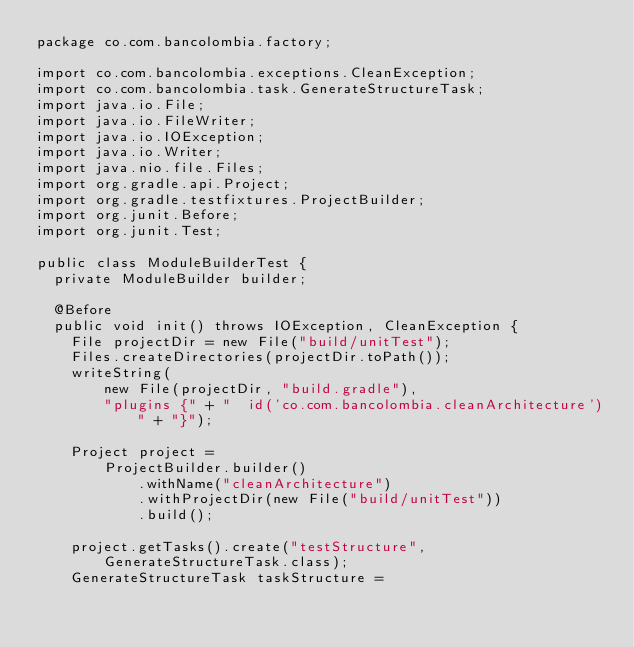<code> <loc_0><loc_0><loc_500><loc_500><_Java_>package co.com.bancolombia.factory;

import co.com.bancolombia.exceptions.CleanException;
import co.com.bancolombia.task.GenerateStructureTask;
import java.io.File;
import java.io.FileWriter;
import java.io.IOException;
import java.io.Writer;
import java.nio.file.Files;
import org.gradle.api.Project;
import org.gradle.testfixtures.ProjectBuilder;
import org.junit.Before;
import org.junit.Test;

public class ModuleBuilderTest {
  private ModuleBuilder builder;

  @Before
  public void init() throws IOException, CleanException {
    File projectDir = new File("build/unitTest");
    Files.createDirectories(projectDir.toPath());
    writeString(
        new File(projectDir, "build.gradle"),
        "plugins {" + "  id('co.com.bancolombia.cleanArchitecture')" + "}");

    Project project =
        ProjectBuilder.builder()
            .withName("cleanArchitecture")
            .withProjectDir(new File("build/unitTest"))
            .build();

    project.getTasks().create("testStructure", GenerateStructureTask.class);
    GenerateStructureTask taskStructure =</code> 